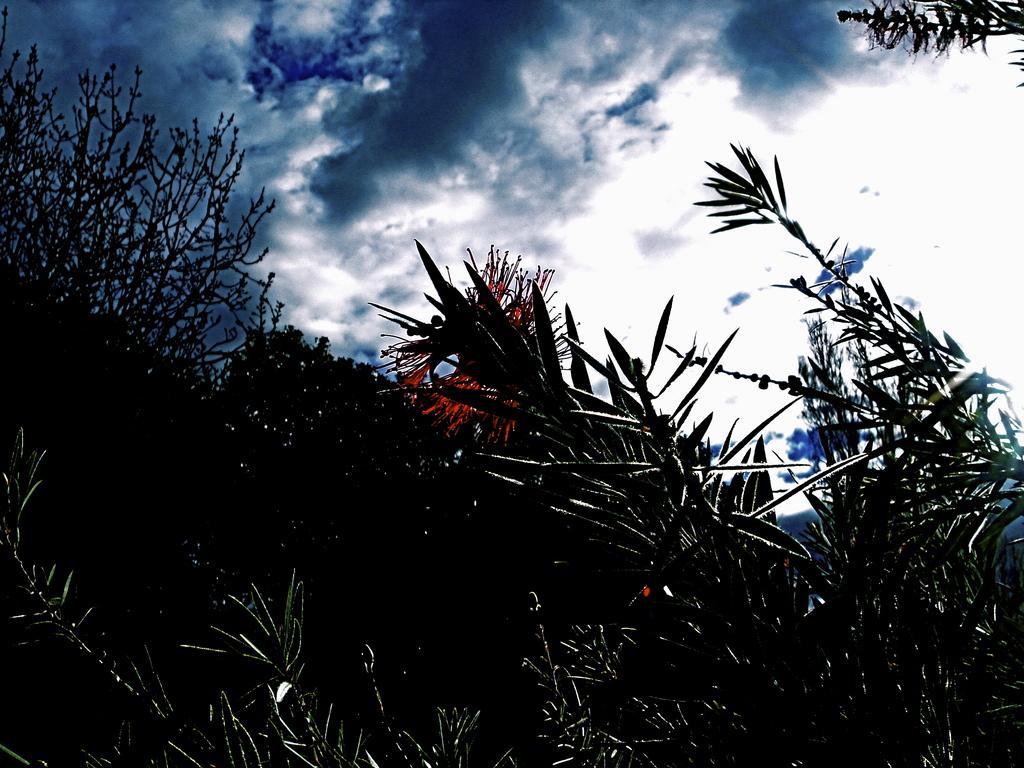Can you describe this image briefly? In this image I can see few plants and few flowers which are red in color. In the background I can see the sky. 